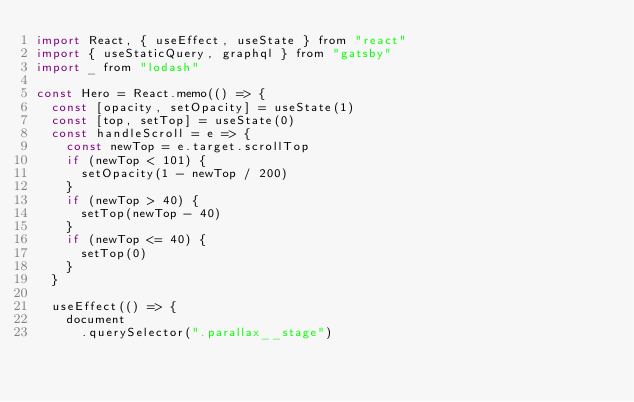<code> <loc_0><loc_0><loc_500><loc_500><_JavaScript_>import React, { useEffect, useState } from "react"
import { useStaticQuery, graphql } from "gatsby"
import _ from "lodash"

const Hero = React.memo(() => {
  const [opacity, setOpacity] = useState(1)
  const [top, setTop] = useState(0)
  const handleScroll = e => {
    const newTop = e.target.scrollTop
    if (newTop < 101) {
      setOpacity(1 - newTop / 200)
    }
    if (newTop > 40) {
      setTop(newTop - 40)
    }
    if (newTop <= 40) {
      setTop(0)
    }
  }

  useEffect(() => {
    document
      .querySelector(".parallax__stage")</code> 